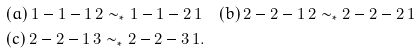Convert formula to latex. <formula><loc_0><loc_0><loc_500><loc_500>& ( a ) \, 1 - 1 - 1 \, 2 \sim _ { * } 1 - 1 - 2 \, 1 \quad ( b ) \, 2 - 2 - 1 \, 2 \sim _ { * } 2 - 2 - 2 \, 1 \\ & ( c ) \, 2 - 2 - 1 \, 3 \sim _ { * } 2 - 2 - 3 \, 1 .</formula> 